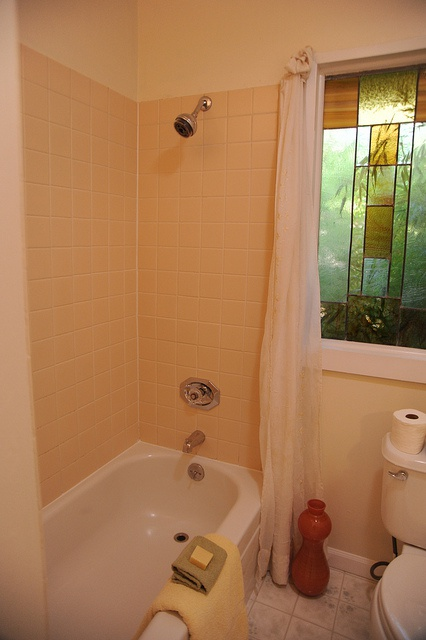Describe the objects in this image and their specific colors. I can see toilet in gray, tan, and brown tones and vase in gray, maroon, and brown tones in this image. 